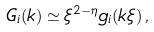<formula> <loc_0><loc_0><loc_500><loc_500>G _ { i } ( { k } ) \simeq \xi ^ { 2 - \eta } g _ { i } ( k \xi ) \, ,</formula> 